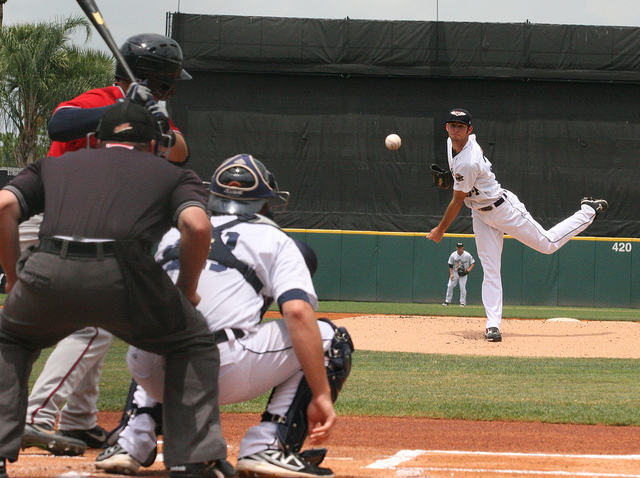Please transcribe the text information in this image. 1 420 